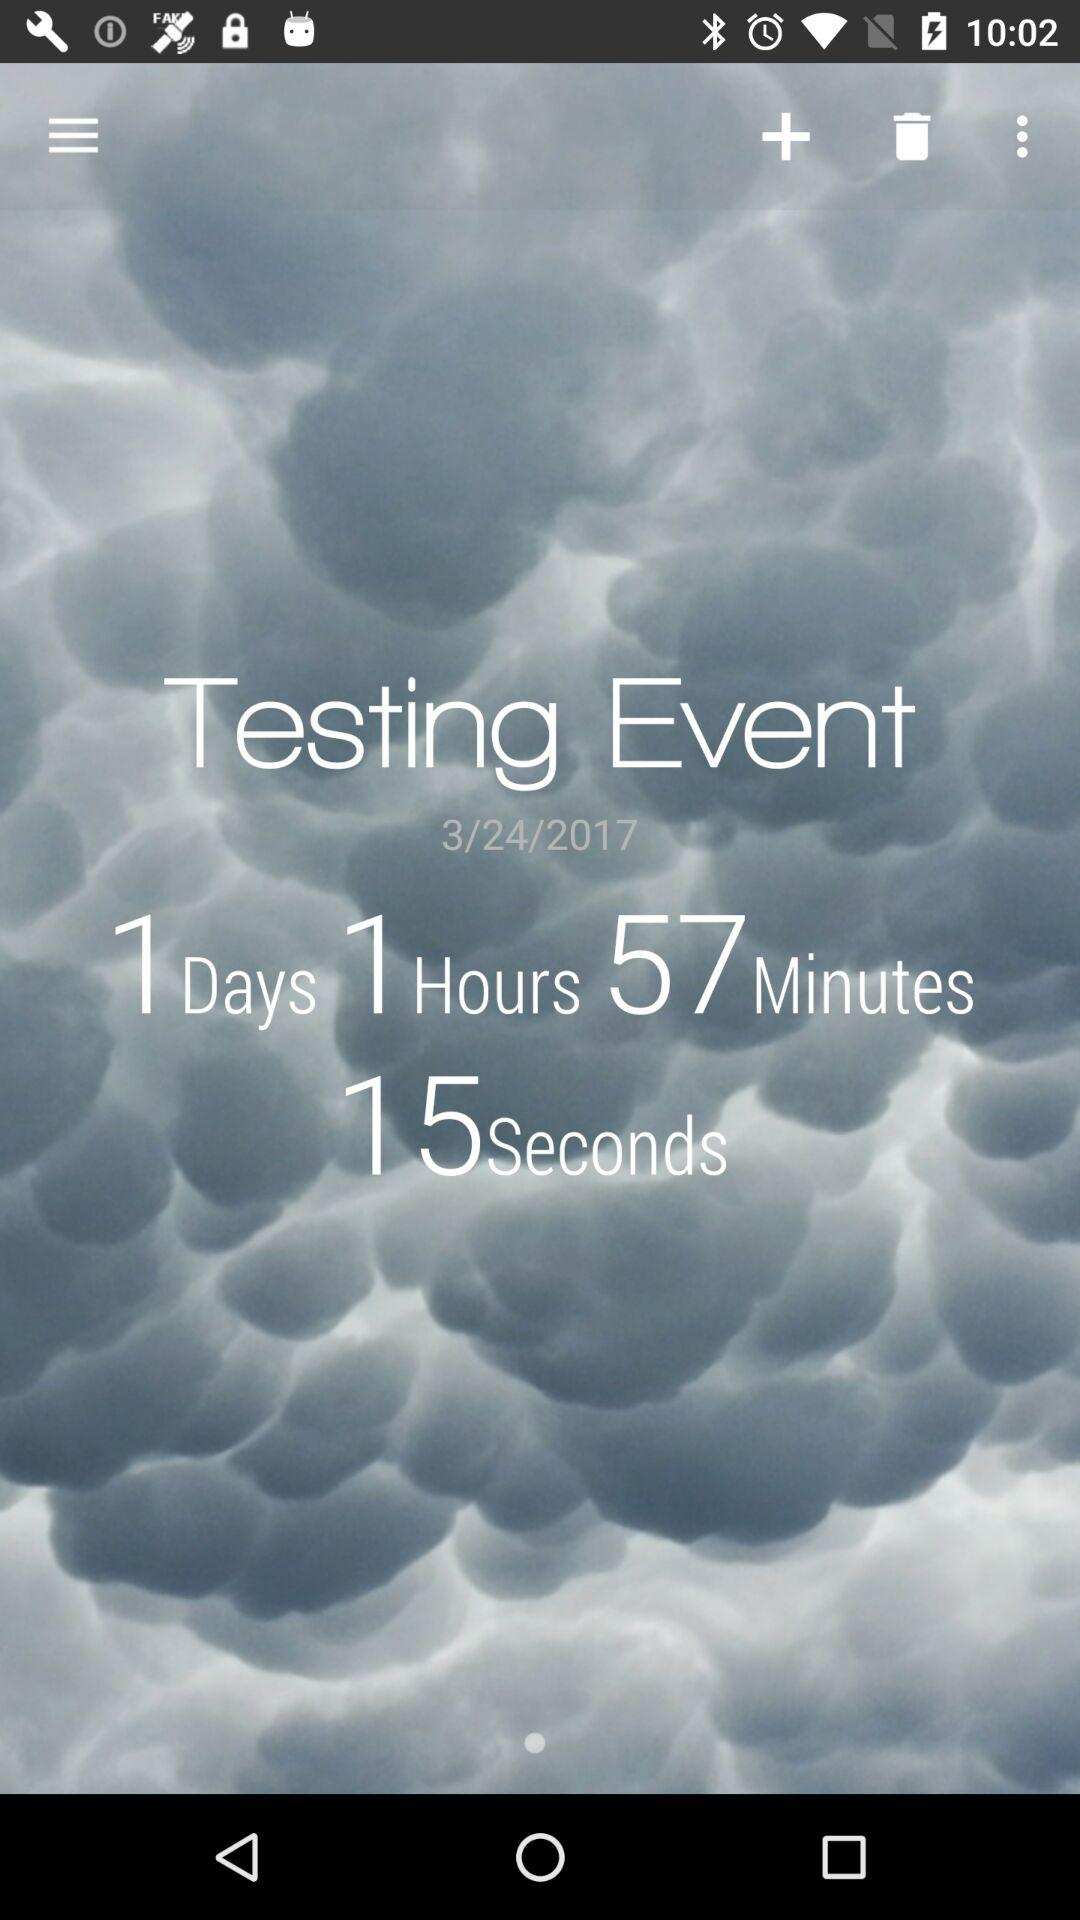What's the "Testing Event" date? The "Testing Event" date is March 24, 2017. 